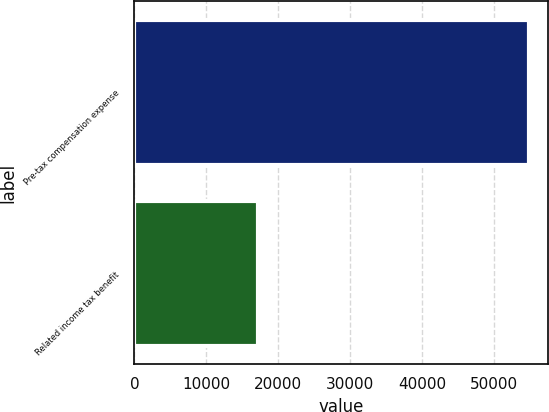<chart> <loc_0><loc_0><loc_500><loc_500><bar_chart><fcel>Pre-tax compensation expense<fcel>Related income tax benefit<nl><fcel>54785<fcel>17148<nl></chart> 